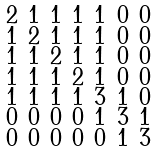<formula> <loc_0><loc_0><loc_500><loc_500>\begin{smallmatrix} 2 & 1 & 1 & 1 & 1 & 0 & 0 \\ 1 & 2 & 1 & 1 & 1 & 0 & 0 \\ 1 & 1 & 2 & 1 & 1 & 0 & 0 \\ 1 & 1 & 1 & 2 & 1 & 0 & 0 \\ 1 & 1 & 1 & 1 & 3 & 1 & 0 \\ 0 & 0 & 0 & 0 & 1 & 3 & 1 \\ 0 & 0 & 0 & 0 & 0 & 1 & 3 \end{smallmatrix}</formula> 